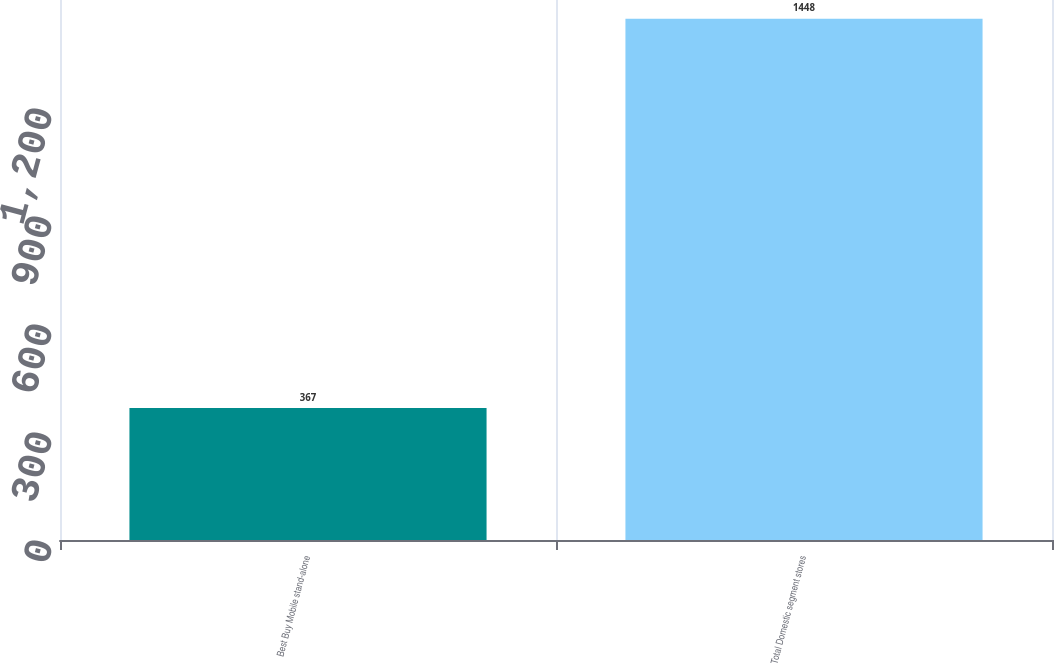Convert chart. <chart><loc_0><loc_0><loc_500><loc_500><bar_chart><fcel>Best Buy Mobile stand-alone<fcel>Total Domestic segment stores<nl><fcel>367<fcel>1448<nl></chart> 